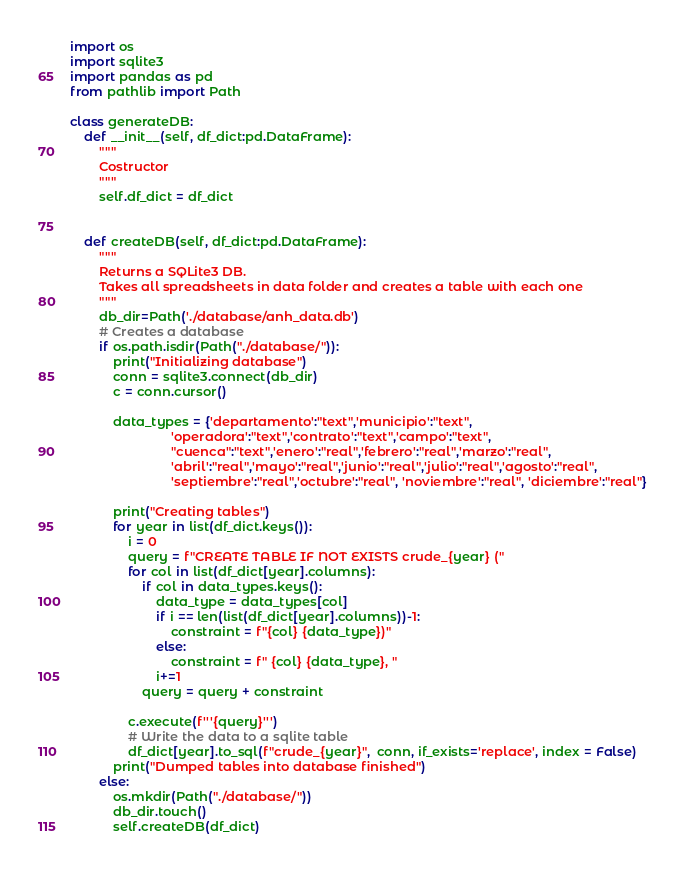Convert code to text. <code><loc_0><loc_0><loc_500><loc_500><_Python_>import os
import sqlite3
import pandas as pd
from pathlib import Path

class generateDB:
    def __init__(self, df_dict:pd.DataFrame):
        """
        Costructor
        """
        self.df_dict = df_dict


    def createDB(self, df_dict:pd.DataFrame):
        """
        Returns a SQLite3 DB.
        Takes all spreadsheets in data folder and creates a table with each one
        """
        db_dir=Path('./database/anh_data.db')
        # Creates a database
        if os.path.isdir(Path("./database/")):
            print("Initializing database")
            conn = sqlite3.connect(db_dir)
            c = conn.cursor()

            data_types = {'departamento':"text",'municipio':"text",
                            'operadora':"text",'contrato':"text",'campo':"text",
                            "cuenca":"text",'enero':"real",'febrero':"real",'marzo':"real",
                            'abril':"real",'mayo':"real",'junio':"real",'julio':"real",'agosto':"real",
                            'septiembre':"real",'octubre':"real", 'noviembre':"real", 'diciembre':"real"}

            print("Creating tables")
            for year in list(df_dict.keys()):
                i = 0
                query = f"CREATE TABLE IF NOT EXISTS crude_{year} ("
                for col in list(df_dict[year].columns):
                    if col in data_types.keys():
                        data_type = data_types[col]
                        if i == len(list(df_dict[year].columns))-1:
                            constraint = f"{col} {data_type})"
                        else:
                            constraint = f" {col} {data_type}, "
                        i+=1
                    query = query + constraint

                c.execute(f'''{query}''')
                # Write the data to a sqlite table
                df_dict[year].to_sql(f"crude_{year}",  conn, if_exists='replace', index = False)
            print("Dumped tables into database finished")
        else:
            os.mkdir(Path("./database/"))
            db_dir.touch()
            self.createDB(df_dict)
</code> 